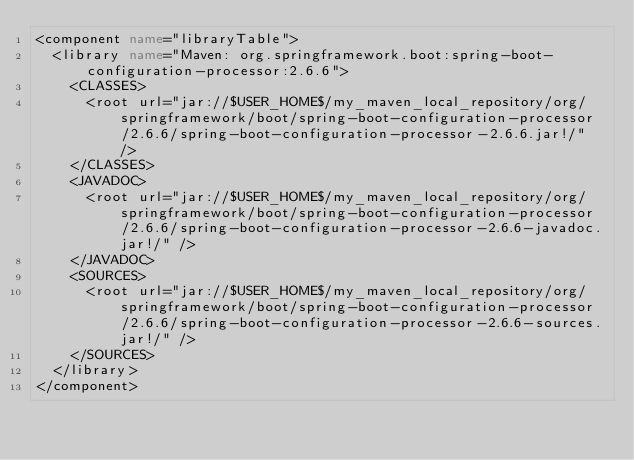<code> <loc_0><loc_0><loc_500><loc_500><_XML_><component name="libraryTable">
  <library name="Maven: org.springframework.boot:spring-boot-configuration-processor:2.6.6">
    <CLASSES>
      <root url="jar://$USER_HOME$/my_maven_local_repository/org/springframework/boot/spring-boot-configuration-processor/2.6.6/spring-boot-configuration-processor-2.6.6.jar!/" />
    </CLASSES>
    <JAVADOC>
      <root url="jar://$USER_HOME$/my_maven_local_repository/org/springframework/boot/spring-boot-configuration-processor/2.6.6/spring-boot-configuration-processor-2.6.6-javadoc.jar!/" />
    </JAVADOC>
    <SOURCES>
      <root url="jar://$USER_HOME$/my_maven_local_repository/org/springframework/boot/spring-boot-configuration-processor/2.6.6/spring-boot-configuration-processor-2.6.6-sources.jar!/" />
    </SOURCES>
  </library>
</component></code> 